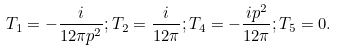<formula> <loc_0><loc_0><loc_500><loc_500>T _ { 1 } = - \frac { i } { 1 2 \pi p ^ { 2 } } ; T _ { 2 } = \frac { i } { 1 2 \pi } ; T _ { 4 } = - \frac { i p ^ { 2 } } { 1 2 \pi } ; T _ { 5 } = 0 .</formula> 